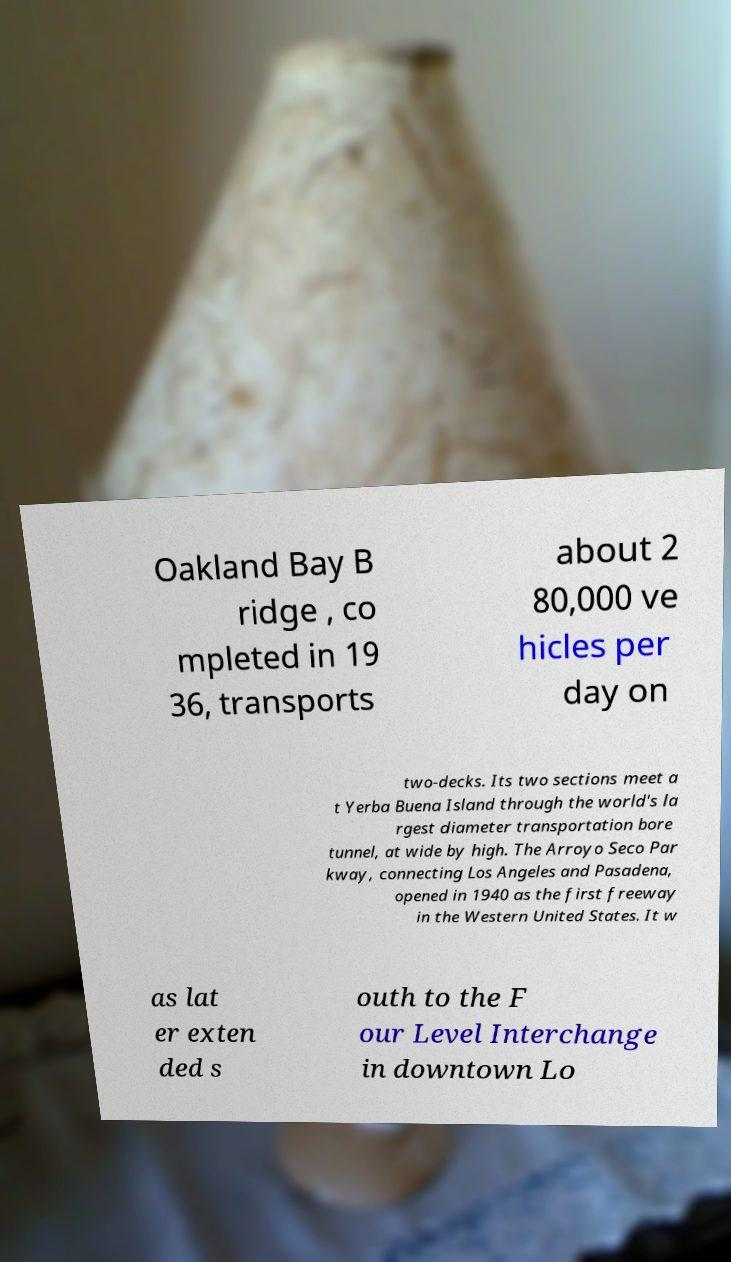For documentation purposes, I need the text within this image transcribed. Could you provide that? Oakland Bay B ridge , co mpleted in 19 36, transports about 2 80,000 ve hicles per day on two-decks. Its two sections meet a t Yerba Buena Island through the world's la rgest diameter transportation bore tunnel, at wide by high. The Arroyo Seco Par kway, connecting Los Angeles and Pasadena, opened in 1940 as the first freeway in the Western United States. It w as lat er exten ded s outh to the F our Level Interchange in downtown Lo 